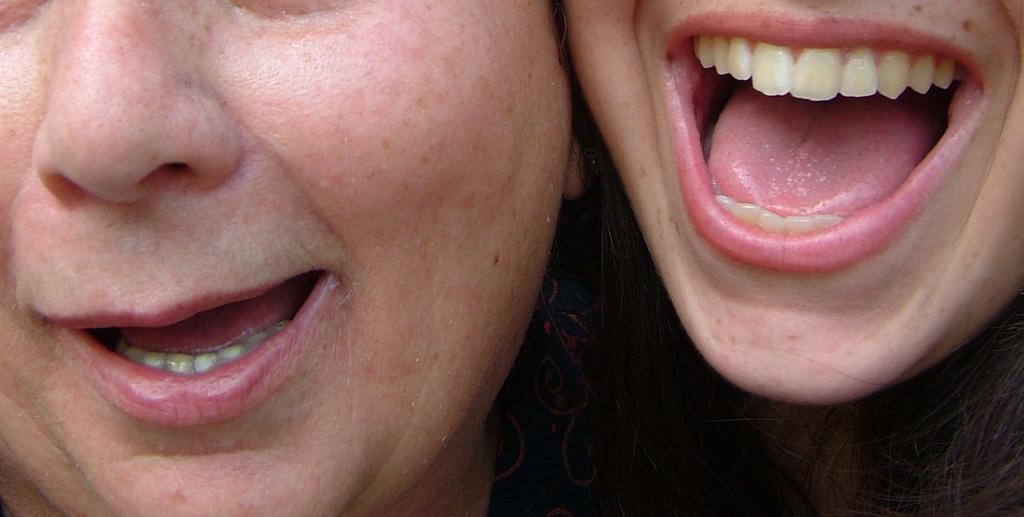How many people are in the image? There are two persons in the image. What is the emotional state of the first person? One person appears to be shouting. What is the emotional state of the second person? The other person is smiling. What type of feather is being used by the person who is shouting? There is no feather present in the image, and the person who is shouting is not using any feather. 